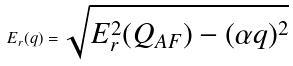Convert formula to latex. <formula><loc_0><loc_0><loc_500><loc_500>E _ { r } ( q ) = \sqrt { E _ { r } ^ { 2 } ( Q _ { A F } ) - ( \alpha q ) ^ { 2 } }</formula> 